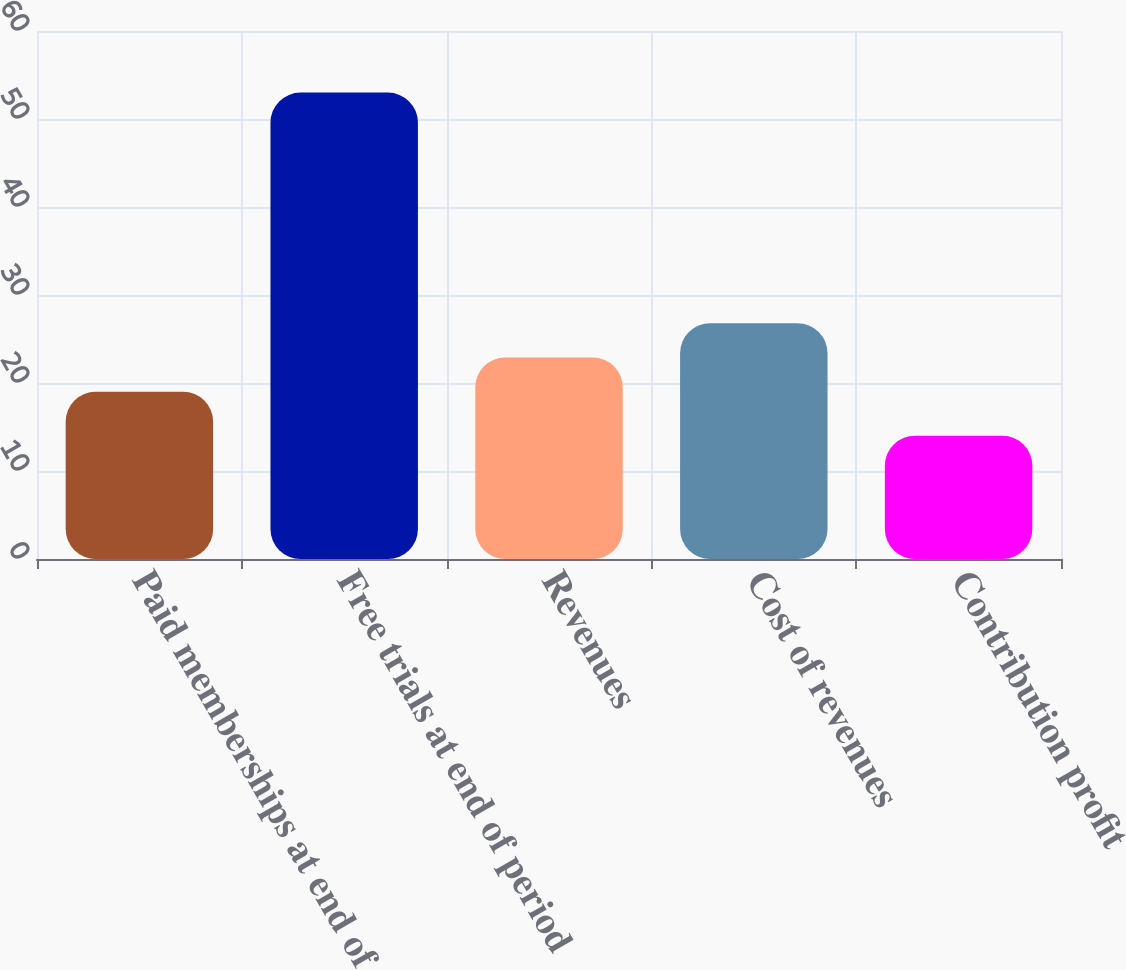<chart> <loc_0><loc_0><loc_500><loc_500><bar_chart><fcel>Paid memberships at end of<fcel>Free trials at end of period<fcel>Revenues<fcel>Cost of revenues<fcel>Contribution profit<nl><fcel>19<fcel>53<fcel>22.9<fcel>26.8<fcel>14<nl></chart> 